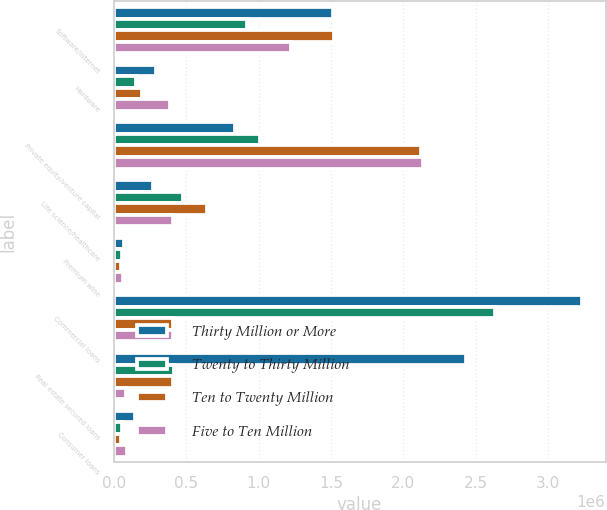Convert chart to OTSL. <chart><loc_0><loc_0><loc_500><loc_500><stacked_bar_chart><ecel><fcel>Software/internet<fcel>Hardware<fcel>Private equity/venture capital<fcel>Life science/healthcare<fcel>Premium wine<fcel>Commercial loans<fcel>Real estate secured loans<fcel>Consumer loans<nl><fcel>Thirty Million or More<fcel>1.5151e+06<fcel>292022<fcel>836894<fcel>273075<fcel>70573<fcel>3.23367e+06<fcel>2.43412e+06<fcel>148391<nl><fcel>Twenty to Thirty Million<fcel>918647<fcel>152061<fcel>1.0126e+06<fcel>477046<fcel>55852<fcel>2.63513e+06<fcel>413282<fcel>55401<nl><fcel>Ten to Twenty Million<fcel>1.52063e+06<fcel>196763<fcel>2.12092e+06<fcel>645895<fcel>48656<fcel>409054<fcel>407980<fcel>51409<nl><fcel>Five to Ten Million<fcel>1.22125e+06<fcel>386288<fcel>2.13528e+06<fcel>410127<fcel>65035<fcel>409054<fcel>83945<fcel>93690<nl></chart> 